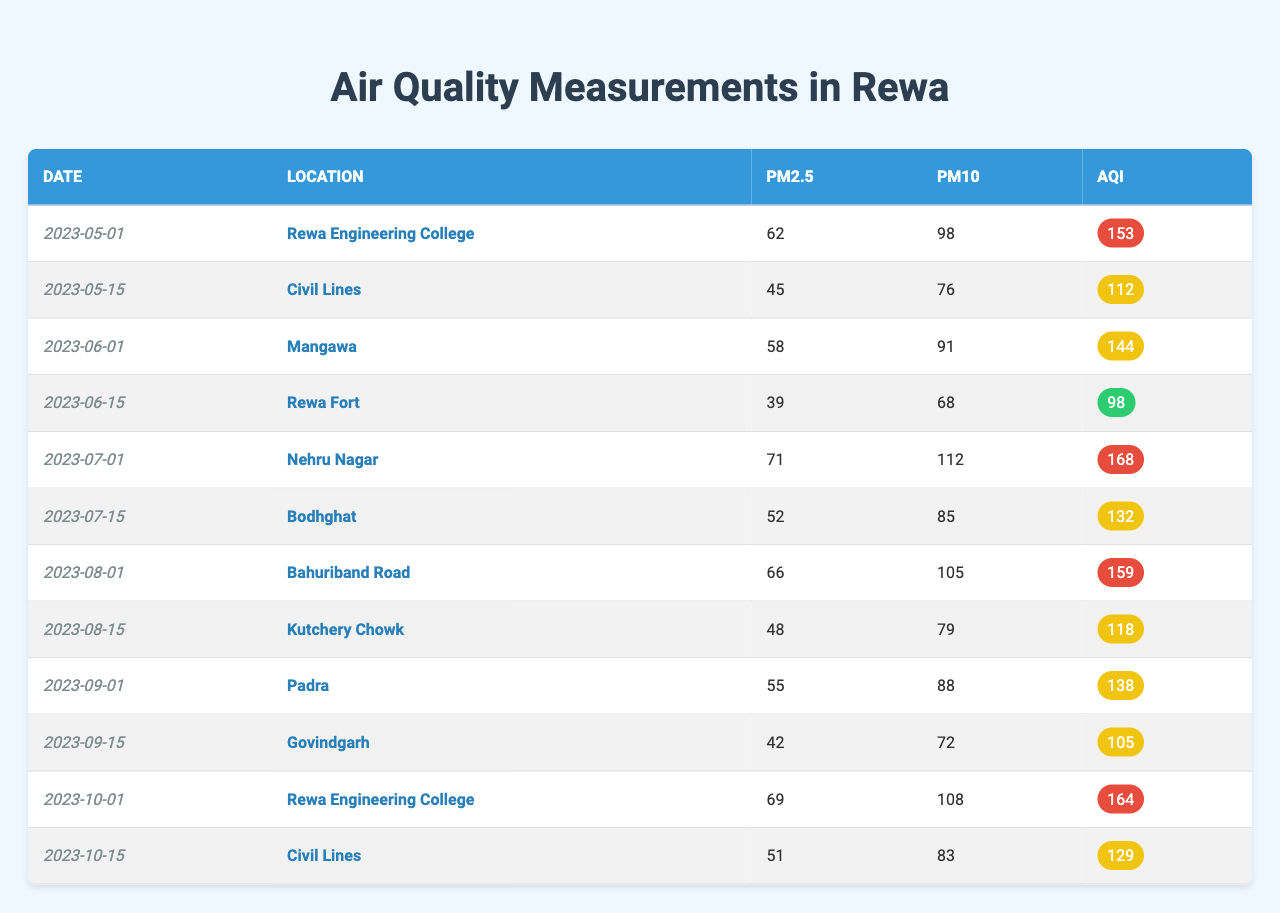What is the AQI reading for Rewa Engineering College on October 1, 2023? In the table, find the row where the location is "Rewa Engineering College" and the date is "2023-10-01". The AQI value for that date and location is stated as 164.
Answer: 164 Which location recorded the highest PM2.5 value, and what was that value? Check each location's PM2.5 column in the table. The highest value is found at "Nehru Nagar" on July 1, 2023, with a PM2.5 reading of 71.
Answer: Nehru Nagar, 71 What was the average AQI across all locations recorded over the six months? Add all AQI values (153 + 112 + 144 + 98 + 168 + 132 + 159 + 118 + 138 + 105 + 164 + 129) = 1,494. There are 12 data points, so the average AQI is 1,494 / 12 = 124.5.
Answer: 124.5 Was the AQI at Civil Lines ever below 100? Look at the entries for Civil Lines in the table. The AQI readings are 112 on May 15 and 129 on October 15. Both values are above 100, indicating no instances below 100.
Answer: No Which two dates had the highest PM10 readings, and what were the values? Review the PM10 column to identify the highest readings. July 1, 2023, had the highest PM10 at 112 and October 1, 2023, had the second highest at 108.
Answer: July 1, 112; October 1, 108 What is the difference in AQI between the highest and lowest recorded values? The highest AQI recorded is 168 on July 1, 2023 (Nehru Nagar) and the lowest is 98 on June 15, 2023 (Rewa Fort). The difference is 168 - 98 = 70.
Answer: 70 On which date did Bahuriband Road record its PM2.5 value, and what was that value? Locate Bahuriband Road in the table, which shows it recorded its PM2.5 value on August 1, 2023, as 66.
Answer: August 1, 66 How does the PM10 level on May 1 compare to that of July 1? Check the PM10 readings for both dates: May 1, 2023, has a PM10 of 98, and July 1, 2023, has a PM10 of 112. The difference, 112 - 98, means it increased by 14.
Answer: Increased by 14 Is there any date when the AQI was classified as "good"? Review all AQI readings in the table to find any that are 100 or below. All AQIs recorded are above 100, indicating no "good" classifications.
Answer: No What trend do you observe in the PM2.5 levels from May to October? Look at the PM2.5 values over the months (62, 45, 58, 39, 71, 52, 66, 48, 55, 42, 69, 51) to deduce that the values generally fluctuate, with noticeable peaks and drops.
Answer: Fluctuating trend with peaks and drops 